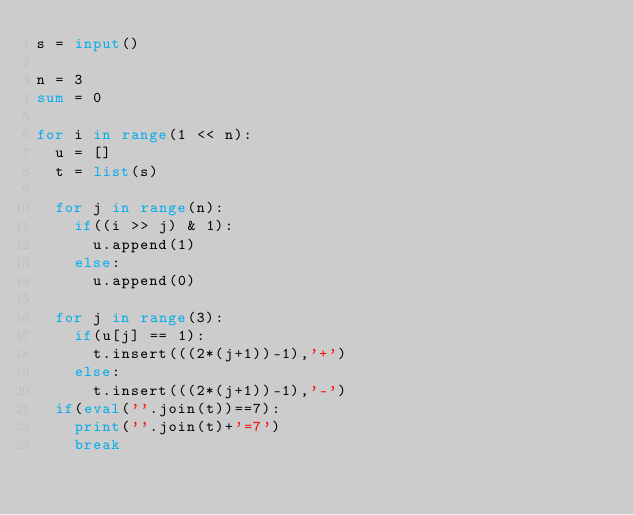<code> <loc_0><loc_0><loc_500><loc_500><_Python_>s = input()

n = 3
sum = 0

for i in range(1 << n):
  u = []
  t = list(s)
  
  for j in range(n):
    if((i >> j) & 1):
      u.append(1)
    else:
      u.append(0)
  
  for j in range(3):
    if(u[j] == 1):
      t.insert(((2*(j+1))-1),'+')
    else:
      t.insert(((2*(j+1))-1),'-')
  if(eval(''.join(t))==7):
    print(''.join(t)+'=7')
    break</code> 